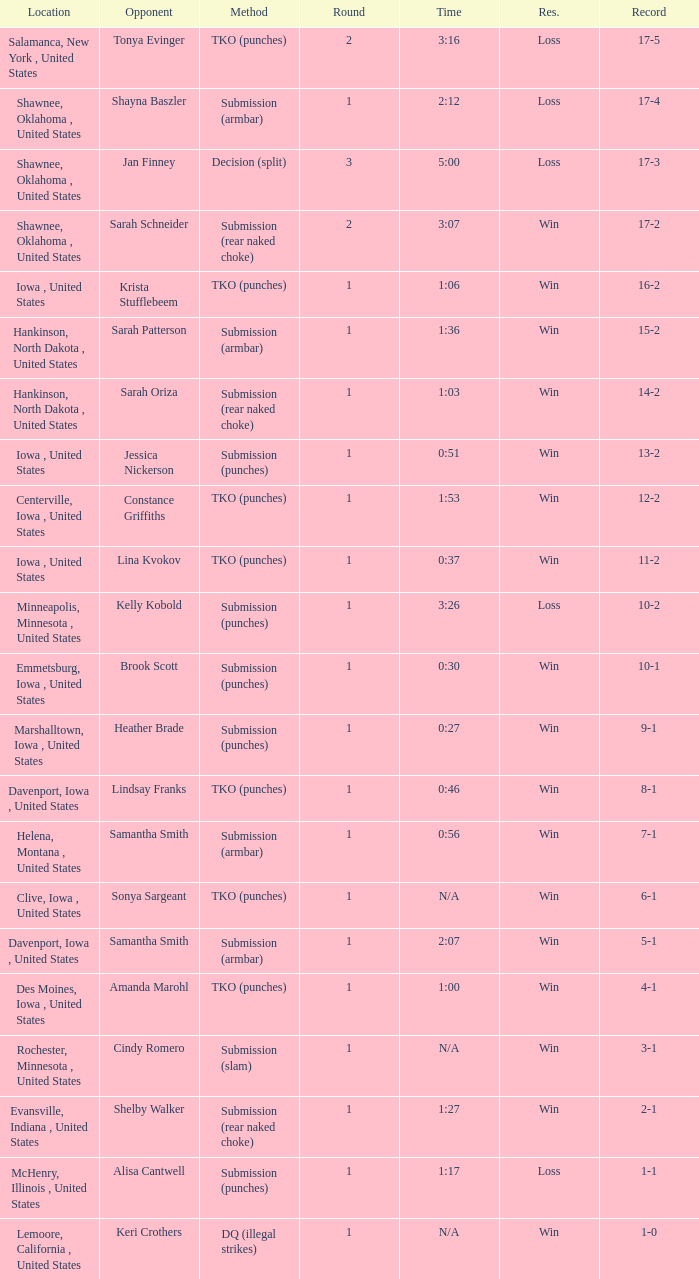What is the highest number of rounds for a 3:16 fight? 2.0. 